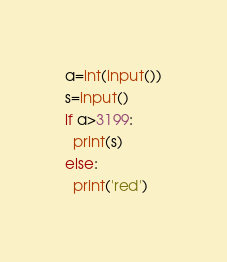Convert code to text. <code><loc_0><loc_0><loc_500><loc_500><_Python_>a=int(input())
s=input()
if a>3199:
  print(s)
else:
  print('red')
</code> 